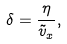Convert formula to latex. <formula><loc_0><loc_0><loc_500><loc_500>\delta = \frac { \eta } { \tilde { v } _ { x } } ,</formula> 